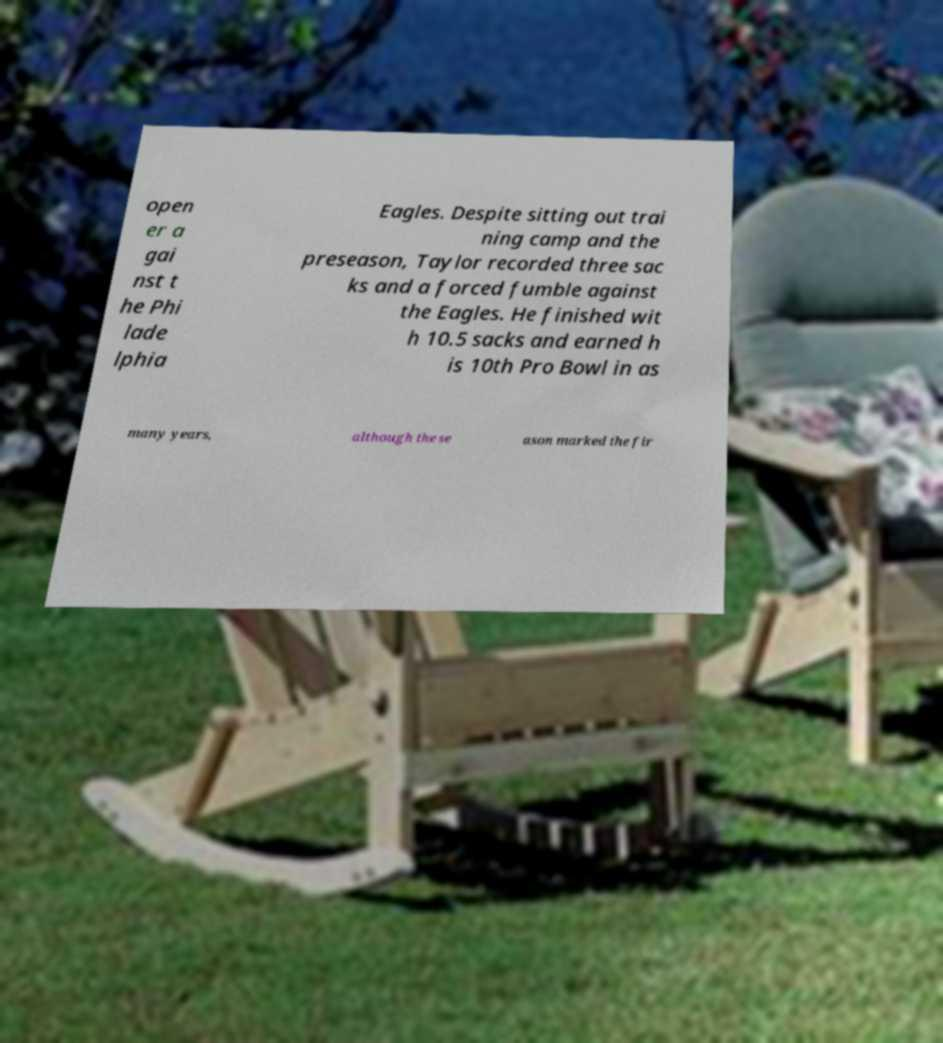What messages or text are displayed in this image? I need them in a readable, typed format. open er a gai nst t he Phi lade lphia Eagles. Despite sitting out trai ning camp and the preseason, Taylor recorded three sac ks and a forced fumble against the Eagles. He finished wit h 10.5 sacks and earned h is 10th Pro Bowl in as many years, although the se ason marked the fir 